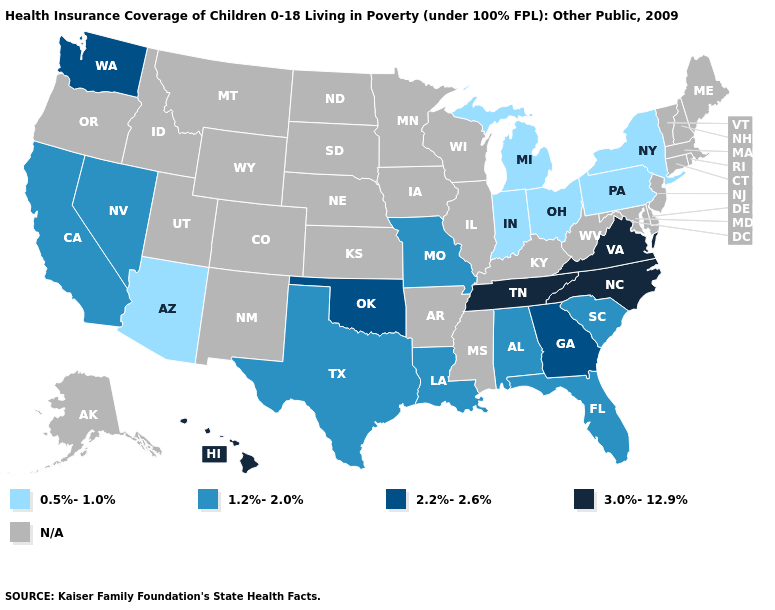What is the value of Mississippi?
Quick response, please. N/A. Name the states that have a value in the range 1.2%-2.0%?
Short answer required. Alabama, California, Florida, Louisiana, Missouri, Nevada, South Carolina, Texas. What is the highest value in the West ?
Answer briefly. 3.0%-12.9%. What is the highest value in the West ?
Quick response, please. 3.0%-12.9%. Name the states that have a value in the range 0.5%-1.0%?
Concise answer only. Arizona, Indiana, Michigan, New York, Ohio, Pennsylvania. What is the highest value in the USA?
Quick response, please. 3.0%-12.9%. Does Arizona have the lowest value in the USA?
Give a very brief answer. Yes. What is the lowest value in the USA?
Be succinct. 0.5%-1.0%. What is the lowest value in the USA?
Keep it brief. 0.5%-1.0%. Name the states that have a value in the range 3.0%-12.9%?
Give a very brief answer. Hawaii, North Carolina, Tennessee, Virginia. Does the first symbol in the legend represent the smallest category?
Give a very brief answer. Yes. How many symbols are there in the legend?
Give a very brief answer. 5. Which states have the lowest value in the South?
Concise answer only. Alabama, Florida, Louisiana, South Carolina, Texas. Is the legend a continuous bar?
Concise answer only. No. What is the lowest value in states that border Colorado?
Quick response, please. 0.5%-1.0%. 